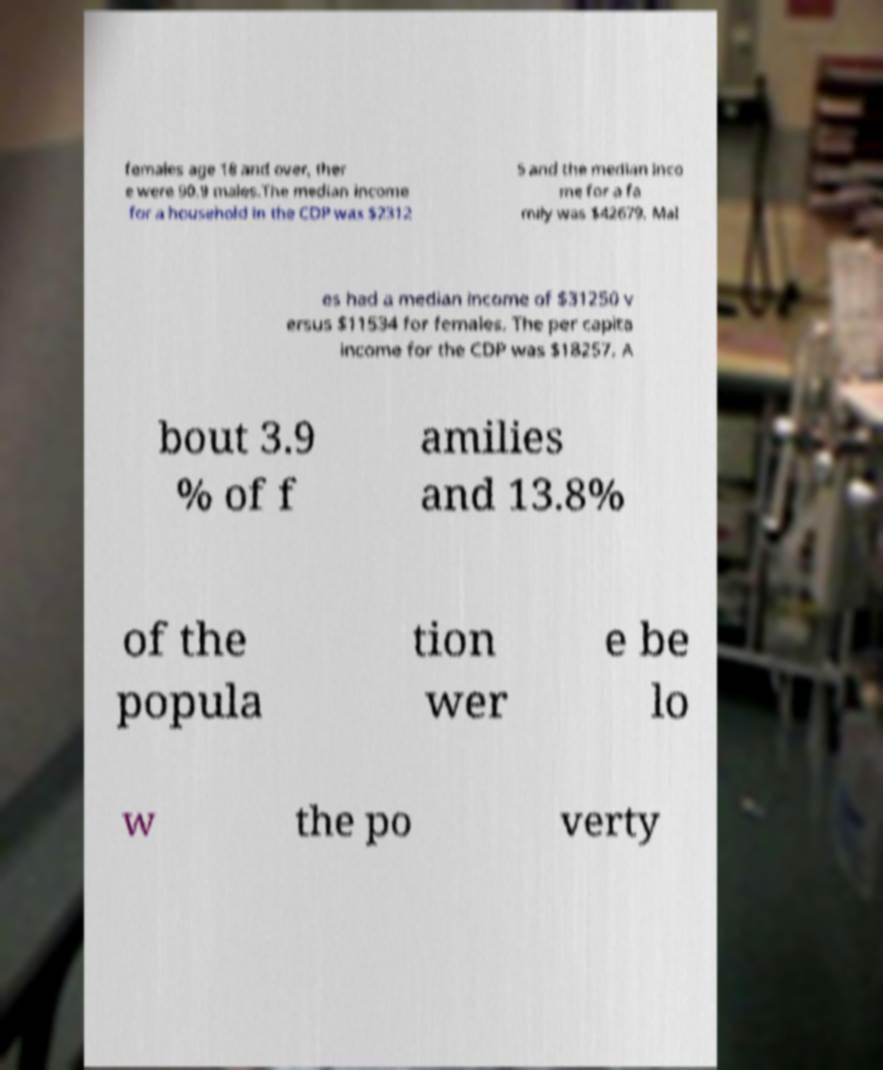Could you extract and type out the text from this image? females age 18 and over, ther e were 90.9 males.The median income for a household in the CDP was $2312 5 and the median inco me for a fa mily was $42679. Mal es had a median income of $31250 v ersus $11534 for females. The per capita income for the CDP was $18257. A bout 3.9 % of f amilies and 13.8% of the popula tion wer e be lo w the po verty 